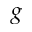Convert formula to latex. <formula><loc_0><loc_0><loc_500><loc_500>g</formula> 